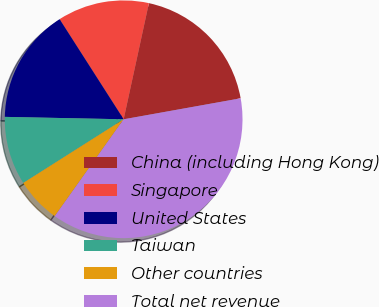Convert chart to OTSL. <chart><loc_0><loc_0><loc_500><loc_500><pie_chart><fcel>China (including Hong Kong)<fcel>Singapore<fcel>United States<fcel>Taiwan<fcel>Other countries<fcel>Total net revenue<nl><fcel>18.77%<fcel>12.47%<fcel>15.62%<fcel>9.32%<fcel>6.17%<fcel>37.67%<nl></chart> 